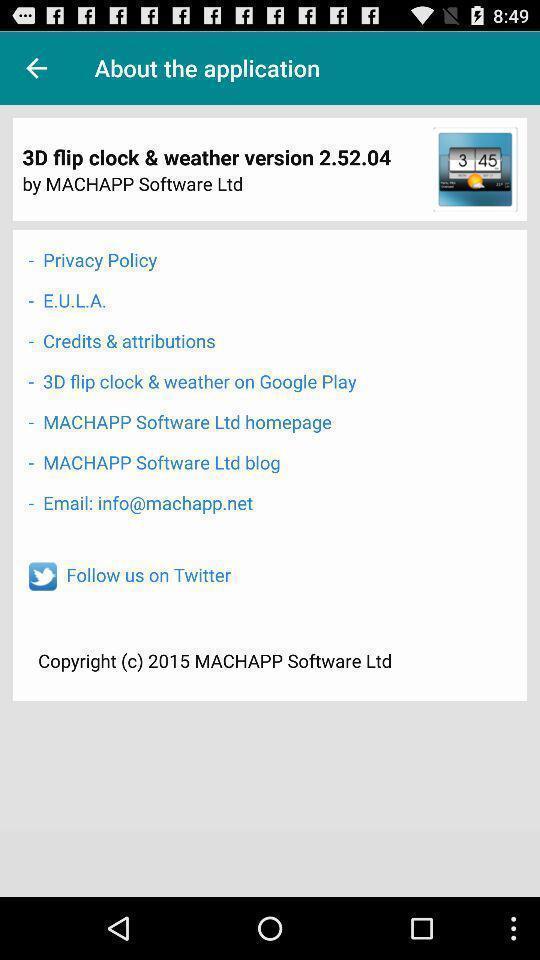Describe the key features of this screenshot. Page showing the various option in about tab. 